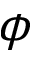Convert formula to latex. <formula><loc_0><loc_0><loc_500><loc_500>\phi</formula> 